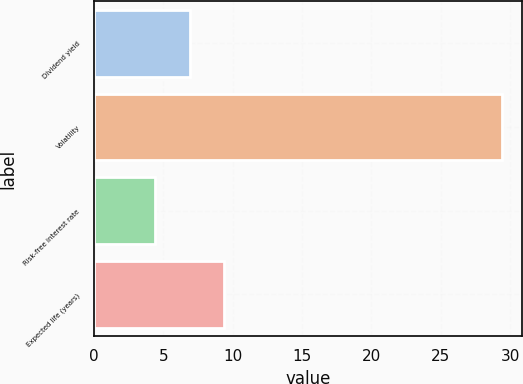<chart> <loc_0><loc_0><loc_500><loc_500><bar_chart><fcel>Dividend yield<fcel>Volatility<fcel>Risk-free interest rate<fcel>Expected life (years)<nl><fcel>6.9<fcel>29.4<fcel>4.4<fcel>9.4<nl></chart> 